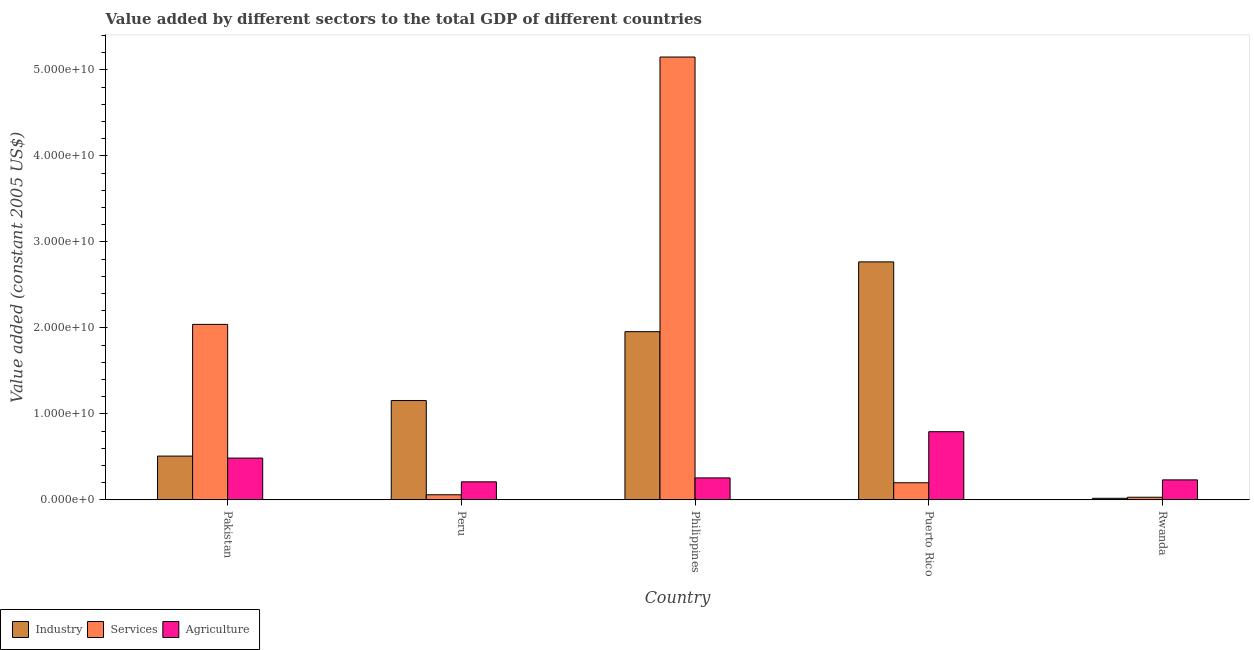How many bars are there on the 5th tick from the left?
Make the answer very short. 3. How many bars are there on the 4th tick from the right?
Ensure brevity in your answer.  3. What is the value added by industrial sector in Peru?
Provide a succinct answer. 1.15e+1. Across all countries, what is the maximum value added by services?
Offer a very short reply. 5.15e+1. Across all countries, what is the minimum value added by industrial sector?
Your answer should be compact. 1.81e+08. In which country was the value added by industrial sector maximum?
Ensure brevity in your answer.  Puerto Rico. What is the total value added by industrial sector in the graph?
Your answer should be compact. 6.40e+1. What is the difference between the value added by agricultural sector in Philippines and that in Rwanda?
Ensure brevity in your answer.  2.29e+08. What is the difference between the value added by agricultural sector in Peru and the value added by services in Pakistan?
Offer a very short reply. -1.83e+1. What is the average value added by industrial sector per country?
Your answer should be compact. 1.28e+1. What is the difference between the value added by industrial sector and value added by services in Rwanda?
Keep it short and to the point. -1.21e+08. What is the ratio of the value added by services in Peru to that in Rwanda?
Your answer should be very brief. 1.95. Is the value added by agricultural sector in Peru less than that in Puerto Rico?
Provide a short and direct response. Yes. What is the difference between the highest and the second highest value added by industrial sector?
Your answer should be compact. 8.11e+09. What is the difference between the highest and the lowest value added by services?
Provide a succinct answer. 5.12e+1. What does the 2nd bar from the left in Rwanda represents?
Your response must be concise. Services. What does the 3rd bar from the right in Pakistan represents?
Your response must be concise. Industry. How many bars are there?
Provide a succinct answer. 15. Are all the bars in the graph horizontal?
Give a very brief answer. No. How many countries are there in the graph?
Offer a very short reply. 5. What is the difference between two consecutive major ticks on the Y-axis?
Provide a succinct answer. 1.00e+1. Does the graph contain grids?
Your answer should be very brief. No. Where does the legend appear in the graph?
Ensure brevity in your answer.  Bottom left. How many legend labels are there?
Make the answer very short. 3. What is the title of the graph?
Your response must be concise. Value added by different sectors to the total GDP of different countries. Does "Industrial Nitrous Oxide" appear as one of the legend labels in the graph?
Ensure brevity in your answer.  No. What is the label or title of the Y-axis?
Your response must be concise. Value added (constant 2005 US$). What is the Value added (constant 2005 US$) of Industry in Pakistan?
Offer a terse response. 5.09e+09. What is the Value added (constant 2005 US$) in Services in Pakistan?
Your answer should be compact. 2.04e+1. What is the Value added (constant 2005 US$) in Agriculture in Pakistan?
Provide a short and direct response. 4.85e+09. What is the Value added (constant 2005 US$) in Industry in Peru?
Provide a succinct answer. 1.15e+1. What is the Value added (constant 2005 US$) in Services in Peru?
Offer a terse response. 5.91e+08. What is the Value added (constant 2005 US$) in Agriculture in Peru?
Offer a very short reply. 2.09e+09. What is the Value added (constant 2005 US$) in Industry in Philippines?
Your answer should be compact. 1.96e+1. What is the Value added (constant 2005 US$) of Services in Philippines?
Ensure brevity in your answer.  5.15e+1. What is the Value added (constant 2005 US$) in Agriculture in Philippines?
Offer a very short reply. 2.55e+09. What is the Value added (constant 2005 US$) of Industry in Puerto Rico?
Give a very brief answer. 2.77e+1. What is the Value added (constant 2005 US$) of Services in Puerto Rico?
Offer a very short reply. 1.99e+09. What is the Value added (constant 2005 US$) of Agriculture in Puerto Rico?
Offer a very short reply. 7.92e+09. What is the Value added (constant 2005 US$) of Industry in Rwanda?
Offer a terse response. 1.81e+08. What is the Value added (constant 2005 US$) of Services in Rwanda?
Your response must be concise. 3.03e+08. What is the Value added (constant 2005 US$) of Agriculture in Rwanda?
Ensure brevity in your answer.  2.32e+09. Across all countries, what is the maximum Value added (constant 2005 US$) in Industry?
Keep it short and to the point. 2.77e+1. Across all countries, what is the maximum Value added (constant 2005 US$) of Services?
Provide a succinct answer. 5.15e+1. Across all countries, what is the maximum Value added (constant 2005 US$) of Agriculture?
Your answer should be compact. 7.92e+09. Across all countries, what is the minimum Value added (constant 2005 US$) of Industry?
Your answer should be compact. 1.81e+08. Across all countries, what is the minimum Value added (constant 2005 US$) of Services?
Your answer should be very brief. 3.03e+08. Across all countries, what is the minimum Value added (constant 2005 US$) of Agriculture?
Keep it short and to the point. 2.09e+09. What is the total Value added (constant 2005 US$) of Industry in the graph?
Provide a succinct answer. 6.40e+1. What is the total Value added (constant 2005 US$) in Services in the graph?
Provide a succinct answer. 7.48e+1. What is the total Value added (constant 2005 US$) of Agriculture in the graph?
Offer a very short reply. 1.97e+1. What is the difference between the Value added (constant 2005 US$) in Industry in Pakistan and that in Peru?
Give a very brief answer. -6.46e+09. What is the difference between the Value added (constant 2005 US$) of Services in Pakistan and that in Peru?
Offer a very short reply. 1.98e+1. What is the difference between the Value added (constant 2005 US$) in Agriculture in Pakistan and that in Peru?
Your answer should be very brief. 2.76e+09. What is the difference between the Value added (constant 2005 US$) of Industry in Pakistan and that in Philippines?
Provide a short and direct response. -1.45e+1. What is the difference between the Value added (constant 2005 US$) of Services in Pakistan and that in Philippines?
Ensure brevity in your answer.  -3.11e+1. What is the difference between the Value added (constant 2005 US$) in Agriculture in Pakistan and that in Philippines?
Provide a succinct answer. 2.30e+09. What is the difference between the Value added (constant 2005 US$) in Industry in Pakistan and that in Puerto Rico?
Keep it short and to the point. -2.26e+1. What is the difference between the Value added (constant 2005 US$) of Services in Pakistan and that in Puerto Rico?
Keep it short and to the point. 1.84e+1. What is the difference between the Value added (constant 2005 US$) of Agriculture in Pakistan and that in Puerto Rico?
Give a very brief answer. -3.07e+09. What is the difference between the Value added (constant 2005 US$) in Industry in Pakistan and that in Rwanda?
Your answer should be compact. 4.91e+09. What is the difference between the Value added (constant 2005 US$) of Services in Pakistan and that in Rwanda?
Offer a very short reply. 2.01e+1. What is the difference between the Value added (constant 2005 US$) of Agriculture in Pakistan and that in Rwanda?
Provide a short and direct response. 2.53e+09. What is the difference between the Value added (constant 2005 US$) of Industry in Peru and that in Philippines?
Give a very brief answer. -8.01e+09. What is the difference between the Value added (constant 2005 US$) of Services in Peru and that in Philippines?
Give a very brief answer. -5.09e+1. What is the difference between the Value added (constant 2005 US$) of Agriculture in Peru and that in Philippines?
Make the answer very short. -4.56e+08. What is the difference between the Value added (constant 2005 US$) in Industry in Peru and that in Puerto Rico?
Your response must be concise. -1.61e+1. What is the difference between the Value added (constant 2005 US$) in Services in Peru and that in Puerto Rico?
Give a very brief answer. -1.40e+09. What is the difference between the Value added (constant 2005 US$) of Agriculture in Peru and that in Puerto Rico?
Provide a short and direct response. -5.83e+09. What is the difference between the Value added (constant 2005 US$) of Industry in Peru and that in Rwanda?
Provide a succinct answer. 1.14e+1. What is the difference between the Value added (constant 2005 US$) in Services in Peru and that in Rwanda?
Give a very brief answer. 2.89e+08. What is the difference between the Value added (constant 2005 US$) in Agriculture in Peru and that in Rwanda?
Your answer should be compact. -2.27e+08. What is the difference between the Value added (constant 2005 US$) in Industry in Philippines and that in Puerto Rico?
Your answer should be compact. -8.11e+09. What is the difference between the Value added (constant 2005 US$) in Services in Philippines and that in Puerto Rico?
Give a very brief answer. 4.95e+1. What is the difference between the Value added (constant 2005 US$) in Agriculture in Philippines and that in Puerto Rico?
Provide a succinct answer. -5.37e+09. What is the difference between the Value added (constant 2005 US$) in Industry in Philippines and that in Rwanda?
Your answer should be compact. 1.94e+1. What is the difference between the Value added (constant 2005 US$) in Services in Philippines and that in Rwanda?
Provide a short and direct response. 5.12e+1. What is the difference between the Value added (constant 2005 US$) of Agriculture in Philippines and that in Rwanda?
Provide a short and direct response. 2.29e+08. What is the difference between the Value added (constant 2005 US$) in Industry in Puerto Rico and that in Rwanda?
Offer a terse response. 2.75e+1. What is the difference between the Value added (constant 2005 US$) in Services in Puerto Rico and that in Rwanda?
Your answer should be compact. 1.68e+09. What is the difference between the Value added (constant 2005 US$) in Agriculture in Puerto Rico and that in Rwanda?
Offer a very short reply. 5.60e+09. What is the difference between the Value added (constant 2005 US$) in Industry in Pakistan and the Value added (constant 2005 US$) in Services in Peru?
Offer a terse response. 4.50e+09. What is the difference between the Value added (constant 2005 US$) in Industry in Pakistan and the Value added (constant 2005 US$) in Agriculture in Peru?
Make the answer very short. 2.99e+09. What is the difference between the Value added (constant 2005 US$) in Services in Pakistan and the Value added (constant 2005 US$) in Agriculture in Peru?
Provide a short and direct response. 1.83e+1. What is the difference between the Value added (constant 2005 US$) in Industry in Pakistan and the Value added (constant 2005 US$) in Services in Philippines?
Provide a succinct answer. -4.64e+1. What is the difference between the Value added (constant 2005 US$) of Industry in Pakistan and the Value added (constant 2005 US$) of Agriculture in Philippines?
Make the answer very short. 2.54e+09. What is the difference between the Value added (constant 2005 US$) in Services in Pakistan and the Value added (constant 2005 US$) in Agriculture in Philippines?
Offer a very short reply. 1.78e+1. What is the difference between the Value added (constant 2005 US$) in Industry in Pakistan and the Value added (constant 2005 US$) in Services in Puerto Rico?
Offer a terse response. 3.10e+09. What is the difference between the Value added (constant 2005 US$) in Industry in Pakistan and the Value added (constant 2005 US$) in Agriculture in Puerto Rico?
Your response must be concise. -2.84e+09. What is the difference between the Value added (constant 2005 US$) of Services in Pakistan and the Value added (constant 2005 US$) of Agriculture in Puerto Rico?
Offer a terse response. 1.25e+1. What is the difference between the Value added (constant 2005 US$) in Industry in Pakistan and the Value added (constant 2005 US$) in Services in Rwanda?
Make the answer very short. 4.78e+09. What is the difference between the Value added (constant 2005 US$) in Industry in Pakistan and the Value added (constant 2005 US$) in Agriculture in Rwanda?
Provide a succinct answer. 2.77e+09. What is the difference between the Value added (constant 2005 US$) of Services in Pakistan and the Value added (constant 2005 US$) of Agriculture in Rwanda?
Give a very brief answer. 1.81e+1. What is the difference between the Value added (constant 2005 US$) in Industry in Peru and the Value added (constant 2005 US$) in Services in Philippines?
Offer a terse response. -3.99e+1. What is the difference between the Value added (constant 2005 US$) in Industry in Peru and the Value added (constant 2005 US$) in Agriculture in Philippines?
Offer a terse response. 8.99e+09. What is the difference between the Value added (constant 2005 US$) in Services in Peru and the Value added (constant 2005 US$) in Agriculture in Philippines?
Your answer should be compact. -1.96e+09. What is the difference between the Value added (constant 2005 US$) of Industry in Peru and the Value added (constant 2005 US$) of Services in Puerto Rico?
Keep it short and to the point. 9.56e+09. What is the difference between the Value added (constant 2005 US$) in Industry in Peru and the Value added (constant 2005 US$) in Agriculture in Puerto Rico?
Your answer should be very brief. 3.62e+09. What is the difference between the Value added (constant 2005 US$) in Services in Peru and the Value added (constant 2005 US$) in Agriculture in Puerto Rico?
Offer a very short reply. -7.33e+09. What is the difference between the Value added (constant 2005 US$) in Industry in Peru and the Value added (constant 2005 US$) in Services in Rwanda?
Ensure brevity in your answer.  1.12e+1. What is the difference between the Value added (constant 2005 US$) in Industry in Peru and the Value added (constant 2005 US$) in Agriculture in Rwanda?
Keep it short and to the point. 9.22e+09. What is the difference between the Value added (constant 2005 US$) of Services in Peru and the Value added (constant 2005 US$) of Agriculture in Rwanda?
Make the answer very short. -1.73e+09. What is the difference between the Value added (constant 2005 US$) in Industry in Philippines and the Value added (constant 2005 US$) in Services in Puerto Rico?
Offer a very short reply. 1.76e+1. What is the difference between the Value added (constant 2005 US$) of Industry in Philippines and the Value added (constant 2005 US$) of Agriculture in Puerto Rico?
Offer a terse response. 1.16e+1. What is the difference between the Value added (constant 2005 US$) of Services in Philippines and the Value added (constant 2005 US$) of Agriculture in Puerto Rico?
Your answer should be compact. 4.36e+1. What is the difference between the Value added (constant 2005 US$) in Industry in Philippines and the Value added (constant 2005 US$) in Services in Rwanda?
Offer a very short reply. 1.93e+1. What is the difference between the Value added (constant 2005 US$) of Industry in Philippines and the Value added (constant 2005 US$) of Agriculture in Rwanda?
Your answer should be compact. 1.72e+1. What is the difference between the Value added (constant 2005 US$) in Services in Philippines and the Value added (constant 2005 US$) in Agriculture in Rwanda?
Offer a very short reply. 4.92e+1. What is the difference between the Value added (constant 2005 US$) in Industry in Puerto Rico and the Value added (constant 2005 US$) in Services in Rwanda?
Your response must be concise. 2.74e+1. What is the difference between the Value added (constant 2005 US$) in Industry in Puerto Rico and the Value added (constant 2005 US$) in Agriculture in Rwanda?
Keep it short and to the point. 2.53e+1. What is the difference between the Value added (constant 2005 US$) of Services in Puerto Rico and the Value added (constant 2005 US$) of Agriculture in Rwanda?
Your answer should be very brief. -3.34e+08. What is the average Value added (constant 2005 US$) in Industry per country?
Keep it short and to the point. 1.28e+1. What is the average Value added (constant 2005 US$) in Services per country?
Provide a short and direct response. 1.50e+1. What is the average Value added (constant 2005 US$) of Agriculture per country?
Provide a succinct answer. 3.95e+09. What is the difference between the Value added (constant 2005 US$) of Industry and Value added (constant 2005 US$) of Services in Pakistan?
Keep it short and to the point. -1.53e+1. What is the difference between the Value added (constant 2005 US$) of Industry and Value added (constant 2005 US$) of Agriculture in Pakistan?
Provide a succinct answer. 2.32e+08. What is the difference between the Value added (constant 2005 US$) of Services and Value added (constant 2005 US$) of Agriculture in Pakistan?
Your answer should be compact. 1.55e+1. What is the difference between the Value added (constant 2005 US$) in Industry and Value added (constant 2005 US$) in Services in Peru?
Provide a short and direct response. 1.10e+1. What is the difference between the Value added (constant 2005 US$) of Industry and Value added (constant 2005 US$) of Agriculture in Peru?
Your response must be concise. 9.45e+09. What is the difference between the Value added (constant 2005 US$) in Services and Value added (constant 2005 US$) in Agriculture in Peru?
Provide a short and direct response. -1.50e+09. What is the difference between the Value added (constant 2005 US$) in Industry and Value added (constant 2005 US$) in Services in Philippines?
Your answer should be compact. -3.19e+1. What is the difference between the Value added (constant 2005 US$) of Industry and Value added (constant 2005 US$) of Agriculture in Philippines?
Ensure brevity in your answer.  1.70e+1. What is the difference between the Value added (constant 2005 US$) in Services and Value added (constant 2005 US$) in Agriculture in Philippines?
Offer a terse response. 4.89e+1. What is the difference between the Value added (constant 2005 US$) of Industry and Value added (constant 2005 US$) of Services in Puerto Rico?
Provide a succinct answer. 2.57e+1. What is the difference between the Value added (constant 2005 US$) of Industry and Value added (constant 2005 US$) of Agriculture in Puerto Rico?
Your answer should be very brief. 1.97e+1. What is the difference between the Value added (constant 2005 US$) of Services and Value added (constant 2005 US$) of Agriculture in Puerto Rico?
Your response must be concise. -5.94e+09. What is the difference between the Value added (constant 2005 US$) in Industry and Value added (constant 2005 US$) in Services in Rwanda?
Ensure brevity in your answer.  -1.21e+08. What is the difference between the Value added (constant 2005 US$) in Industry and Value added (constant 2005 US$) in Agriculture in Rwanda?
Ensure brevity in your answer.  -2.14e+09. What is the difference between the Value added (constant 2005 US$) of Services and Value added (constant 2005 US$) of Agriculture in Rwanda?
Keep it short and to the point. -2.02e+09. What is the ratio of the Value added (constant 2005 US$) in Industry in Pakistan to that in Peru?
Ensure brevity in your answer.  0.44. What is the ratio of the Value added (constant 2005 US$) of Services in Pakistan to that in Peru?
Give a very brief answer. 34.49. What is the ratio of the Value added (constant 2005 US$) of Agriculture in Pakistan to that in Peru?
Your answer should be very brief. 2.32. What is the ratio of the Value added (constant 2005 US$) of Industry in Pakistan to that in Philippines?
Your response must be concise. 0.26. What is the ratio of the Value added (constant 2005 US$) of Services in Pakistan to that in Philippines?
Your answer should be compact. 0.4. What is the ratio of the Value added (constant 2005 US$) in Agriculture in Pakistan to that in Philippines?
Your answer should be very brief. 1.9. What is the ratio of the Value added (constant 2005 US$) of Industry in Pakistan to that in Puerto Rico?
Make the answer very short. 0.18. What is the ratio of the Value added (constant 2005 US$) of Services in Pakistan to that in Puerto Rico?
Give a very brief answer. 10.26. What is the ratio of the Value added (constant 2005 US$) in Agriculture in Pakistan to that in Puerto Rico?
Offer a terse response. 0.61. What is the ratio of the Value added (constant 2005 US$) in Industry in Pakistan to that in Rwanda?
Ensure brevity in your answer.  28.06. What is the ratio of the Value added (constant 2005 US$) of Services in Pakistan to that in Rwanda?
Keep it short and to the point. 67.43. What is the ratio of the Value added (constant 2005 US$) in Agriculture in Pakistan to that in Rwanda?
Provide a short and direct response. 2.09. What is the ratio of the Value added (constant 2005 US$) in Industry in Peru to that in Philippines?
Make the answer very short. 0.59. What is the ratio of the Value added (constant 2005 US$) in Services in Peru to that in Philippines?
Keep it short and to the point. 0.01. What is the ratio of the Value added (constant 2005 US$) in Agriculture in Peru to that in Philippines?
Your response must be concise. 0.82. What is the ratio of the Value added (constant 2005 US$) of Industry in Peru to that in Puerto Rico?
Offer a terse response. 0.42. What is the ratio of the Value added (constant 2005 US$) of Services in Peru to that in Puerto Rico?
Your answer should be compact. 0.3. What is the ratio of the Value added (constant 2005 US$) in Agriculture in Peru to that in Puerto Rico?
Your response must be concise. 0.26. What is the ratio of the Value added (constant 2005 US$) in Industry in Peru to that in Rwanda?
Ensure brevity in your answer.  63.67. What is the ratio of the Value added (constant 2005 US$) of Services in Peru to that in Rwanda?
Your answer should be compact. 1.95. What is the ratio of the Value added (constant 2005 US$) in Agriculture in Peru to that in Rwanda?
Your answer should be very brief. 0.9. What is the ratio of the Value added (constant 2005 US$) of Industry in Philippines to that in Puerto Rico?
Make the answer very short. 0.71. What is the ratio of the Value added (constant 2005 US$) of Services in Philippines to that in Puerto Rico?
Provide a short and direct response. 25.91. What is the ratio of the Value added (constant 2005 US$) in Agriculture in Philippines to that in Puerto Rico?
Your answer should be compact. 0.32. What is the ratio of the Value added (constant 2005 US$) of Industry in Philippines to that in Rwanda?
Give a very brief answer. 107.85. What is the ratio of the Value added (constant 2005 US$) of Services in Philippines to that in Rwanda?
Provide a short and direct response. 170.18. What is the ratio of the Value added (constant 2005 US$) of Agriculture in Philippines to that in Rwanda?
Your response must be concise. 1.1. What is the ratio of the Value added (constant 2005 US$) of Industry in Puerto Rico to that in Rwanda?
Provide a succinct answer. 152.6. What is the ratio of the Value added (constant 2005 US$) of Services in Puerto Rico to that in Rwanda?
Offer a very short reply. 6.57. What is the ratio of the Value added (constant 2005 US$) of Agriculture in Puerto Rico to that in Rwanda?
Your response must be concise. 3.41. What is the difference between the highest and the second highest Value added (constant 2005 US$) of Industry?
Your response must be concise. 8.11e+09. What is the difference between the highest and the second highest Value added (constant 2005 US$) in Services?
Provide a short and direct response. 3.11e+1. What is the difference between the highest and the second highest Value added (constant 2005 US$) in Agriculture?
Make the answer very short. 3.07e+09. What is the difference between the highest and the lowest Value added (constant 2005 US$) in Industry?
Ensure brevity in your answer.  2.75e+1. What is the difference between the highest and the lowest Value added (constant 2005 US$) of Services?
Give a very brief answer. 5.12e+1. What is the difference between the highest and the lowest Value added (constant 2005 US$) in Agriculture?
Make the answer very short. 5.83e+09. 